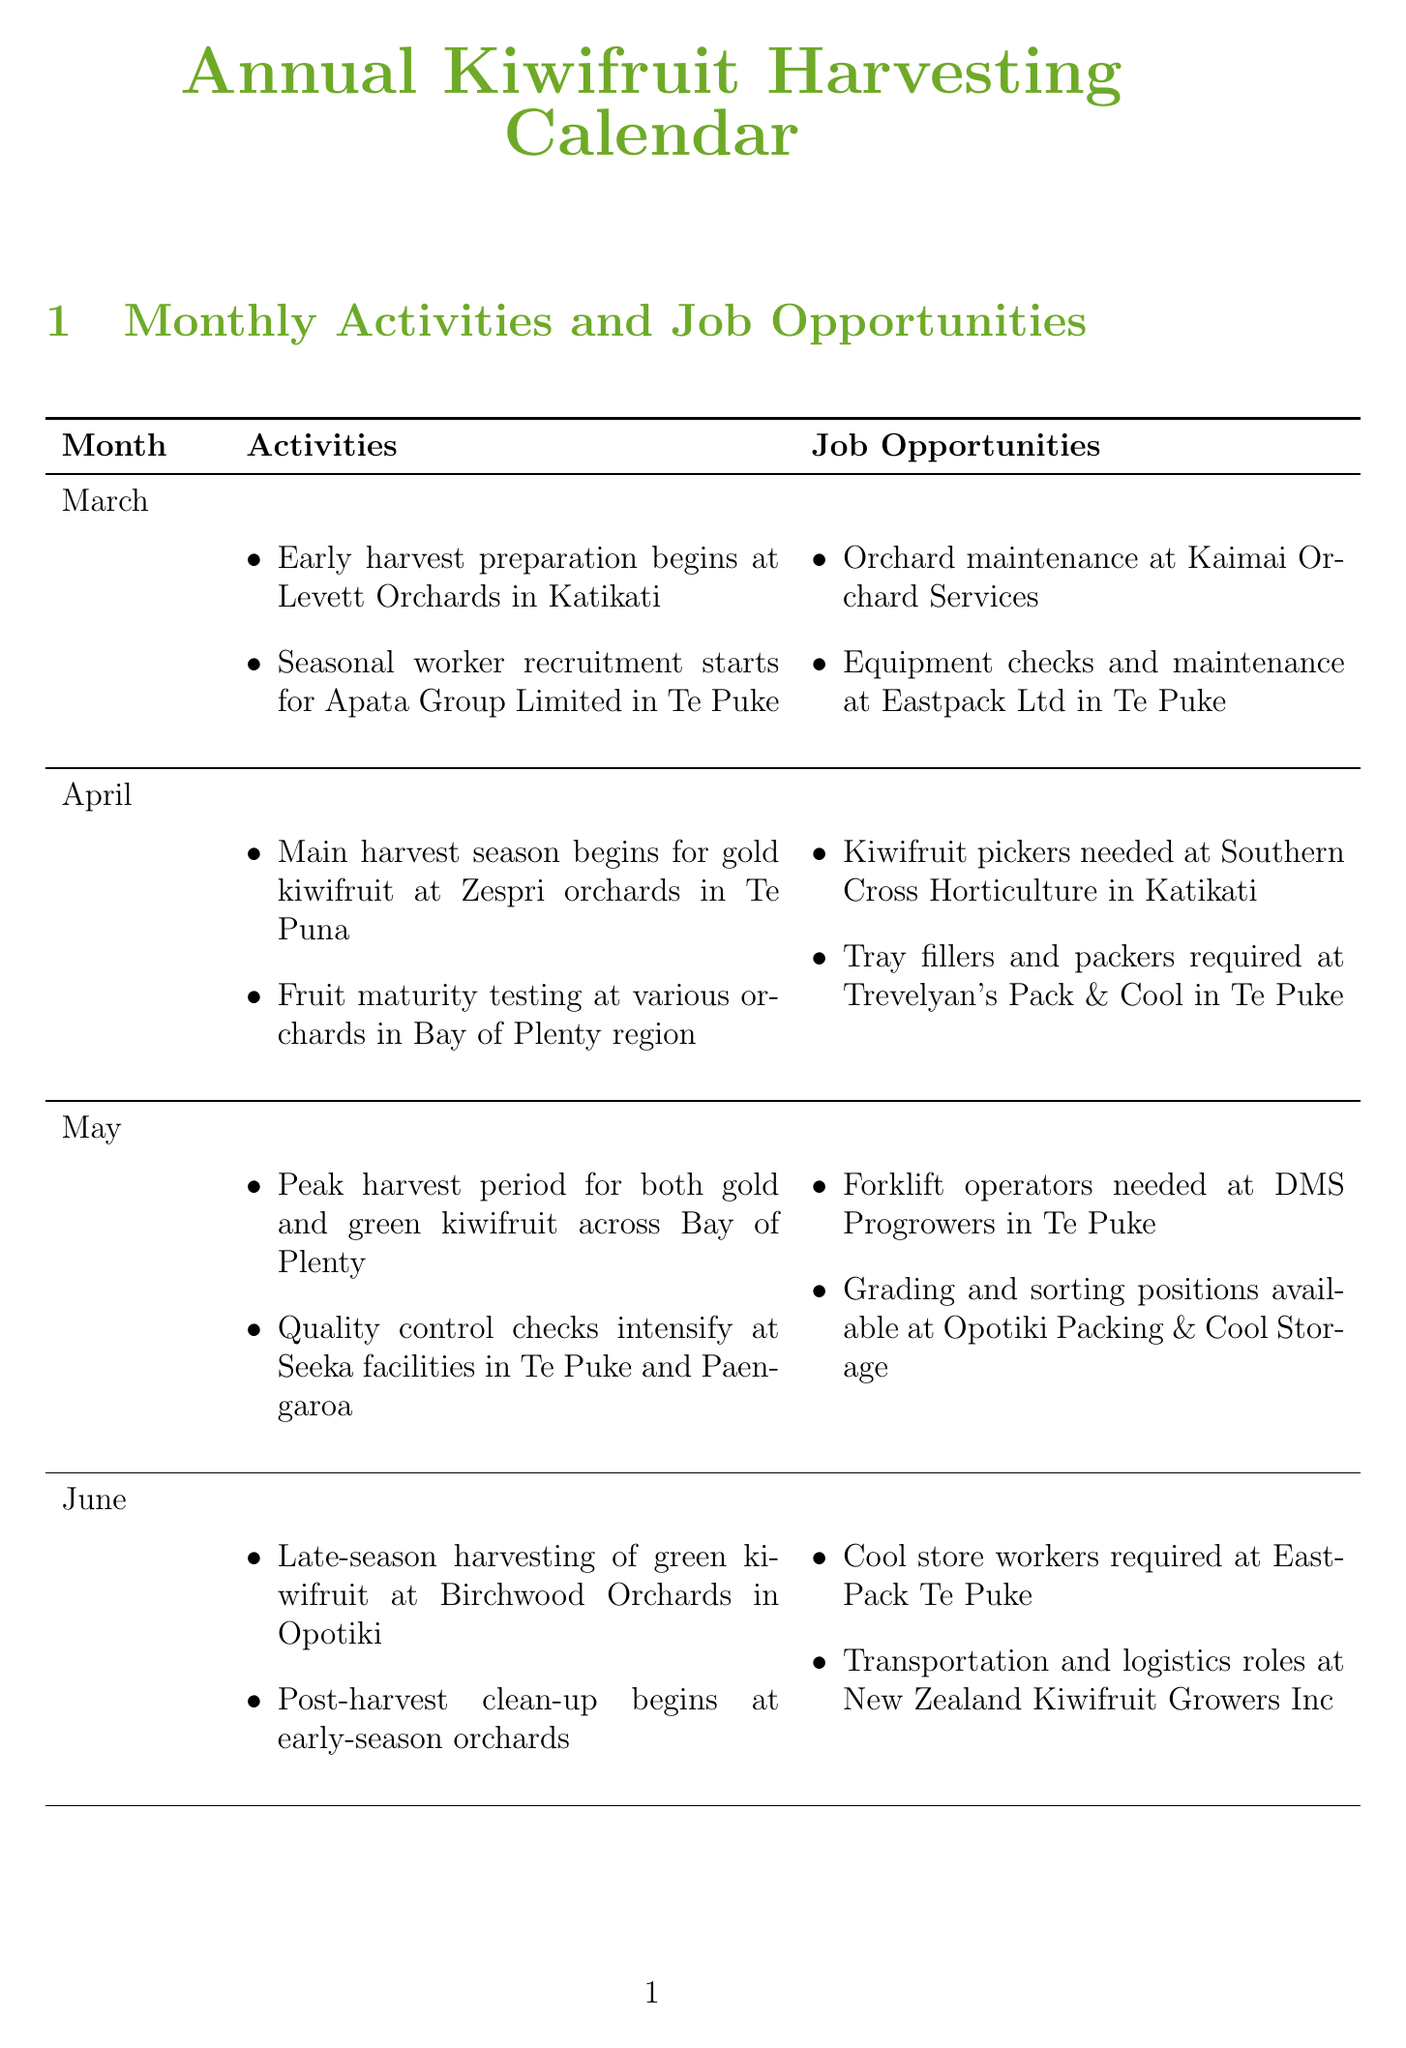What activities begin in March? The activities in March include early harvest preparation at Levett Orchards and seasonal worker recruitment for Apata Group Limited.
Answer: Early harvest preparation begins at Levett Orchards in Katikati, Seasonal worker recruitment starts for Apata Group Limited in Te Puke How far is Waimata Kiwi Gardens from Waihi? Waimata Kiwi Gardens is listed with a specific distance from Waihi in the document.
Answer: 8 km What is required at Trevelyan's Pack & Cool in April? The job opportunities section specifies roles available at Trevelyan's Pack & Cool during April.
Answer: Tray fillers and packers Which orchard has the variety Hayward? The document provides a list of varieties associated with each nearby orchard.
Answer: Waihi Gold Kiwifruit, Athenree Orchard In which month does the peak harvest period occur? The month with the peak harvest period is mentioned in the activities listed for May.
Answer: May What type of position is needed at DMS Progrowers in May? The job opportunities for May indicate specific roles available at DMS Progrowers.
Answer: Forklift operators When is the Bay of Plenty Kiwifruit Growers Forum? The regional kiwifruit events section lists the date of the forum.
Answer: September 15, 2023 What location is associated with the Katikati Kiwifruit Festival? The document specifies the location of the Katikati Kiwifruit Festival.
Answer: Katikati Town Centre 